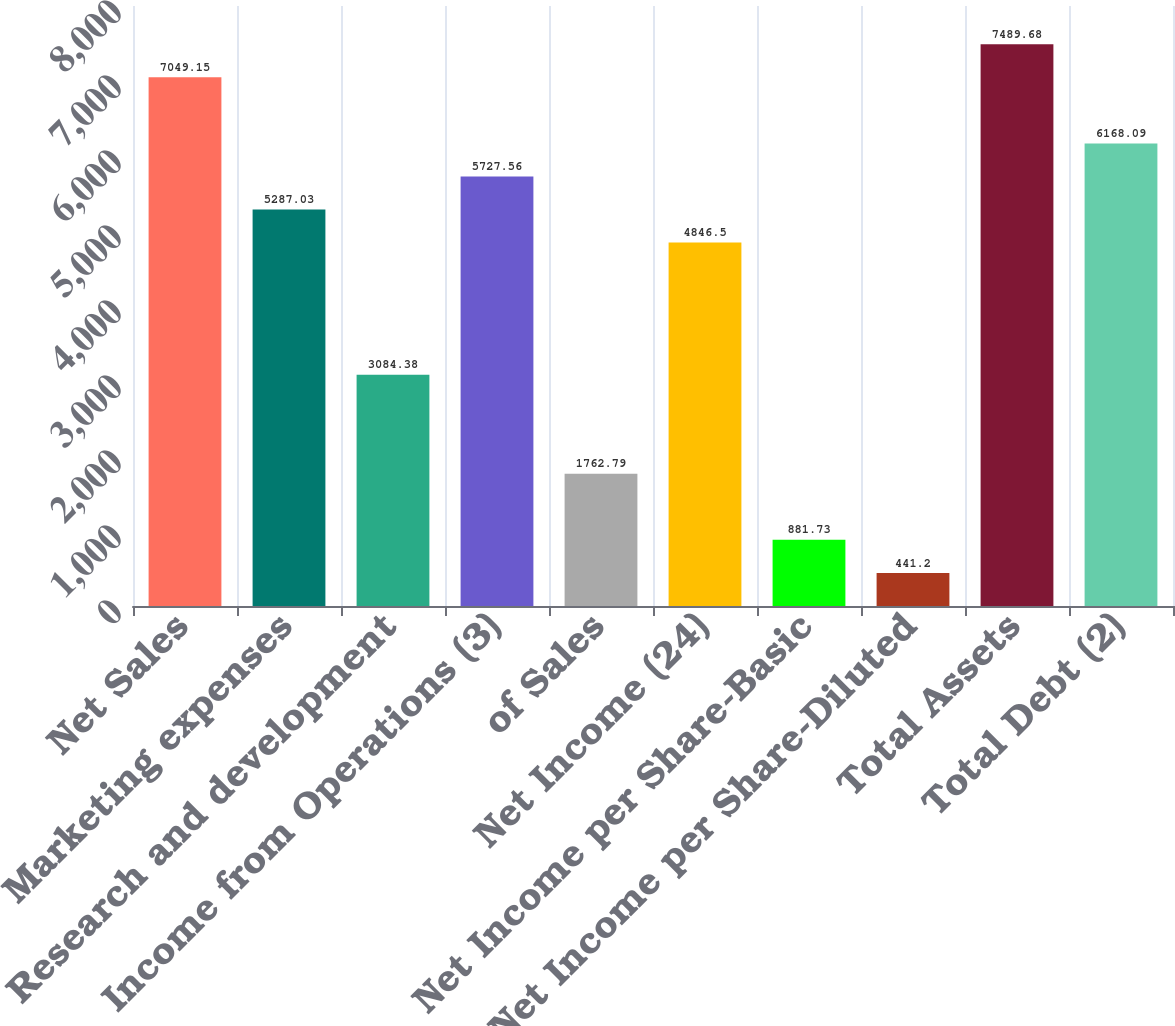<chart> <loc_0><loc_0><loc_500><loc_500><bar_chart><fcel>Net Sales<fcel>Marketing expenses<fcel>Research and development<fcel>Income from Operations (3)<fcel>of Sales<fcel>Net Income (24)<fcel>Net Income per Share-Basic<fcel>Net Income per Share-Diluted<fcel>Total Assets<fcel>Total Debt (2)<nl><fcel>7049.15<fcel>5287.03<fcel>3084.38<fcel>5727.56<fcel>1762.79<fcel>4846.5<fcel>881.73<fcel>441.2<fcel>7489.68<fcel>6168.09<nl></chart> 